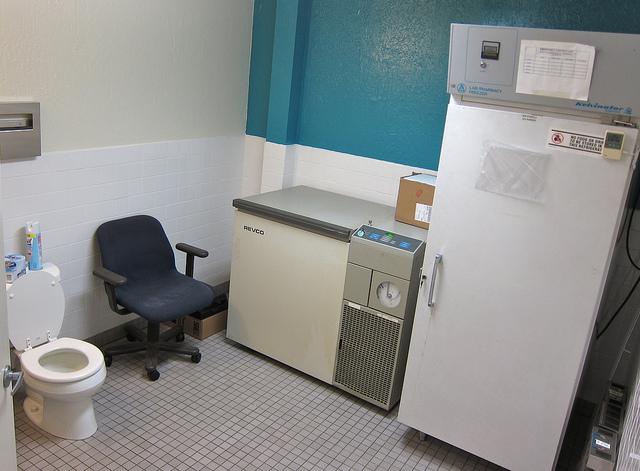What color are the walls behind the toilet?
Write a very short answer. White. Do you normally see a bathroom that looks like this?
Keep it brief. No. Is the chair red and black?
Write a very short answer. No. 